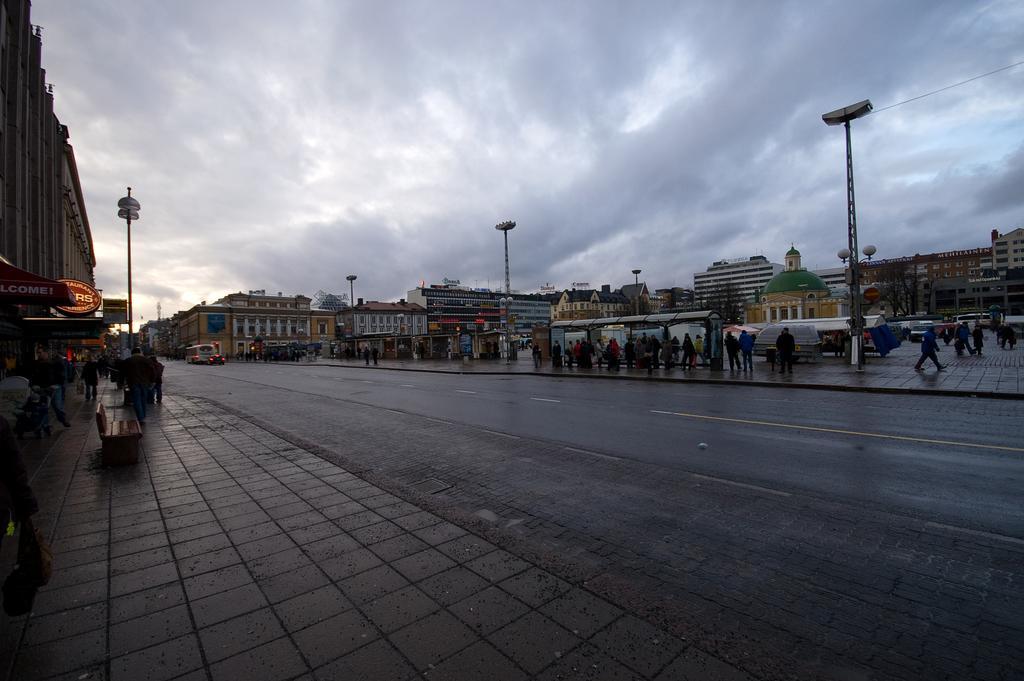Please provide a concise description of this image. In the image there is a road and there are many people on the footpaths, there are some poles on the footpaths and there are some stores and buildings around the road. 